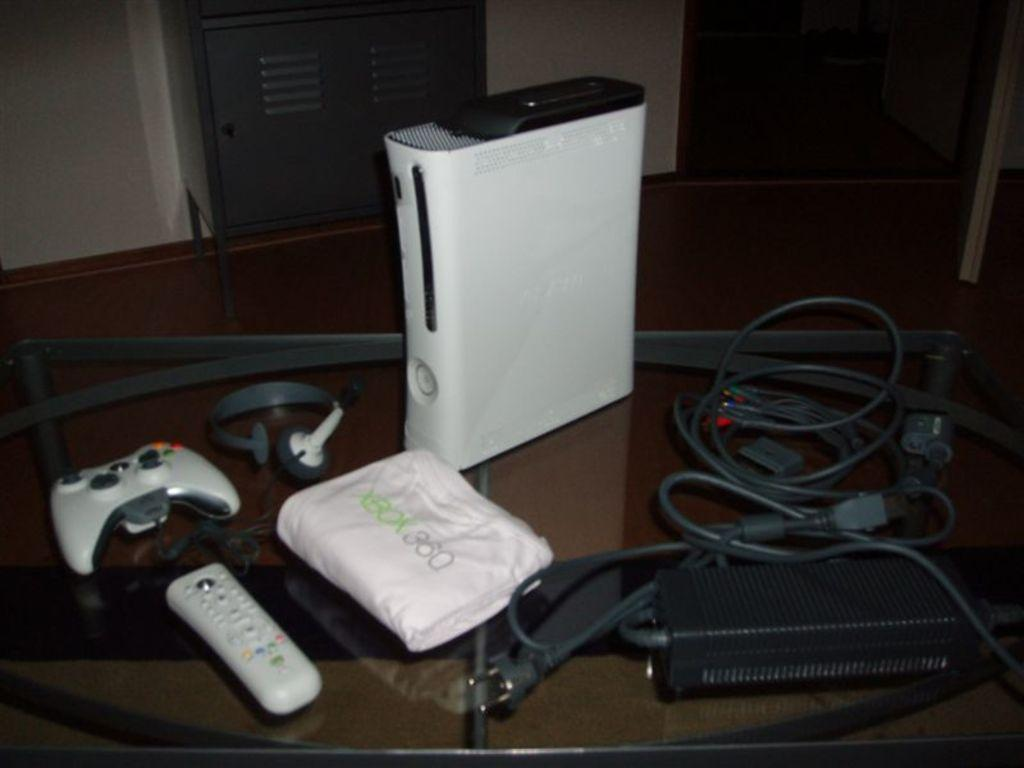<image>
Share a concise interpretation of the image provided. An unboxed XBOX 360 on a glass topped table. 